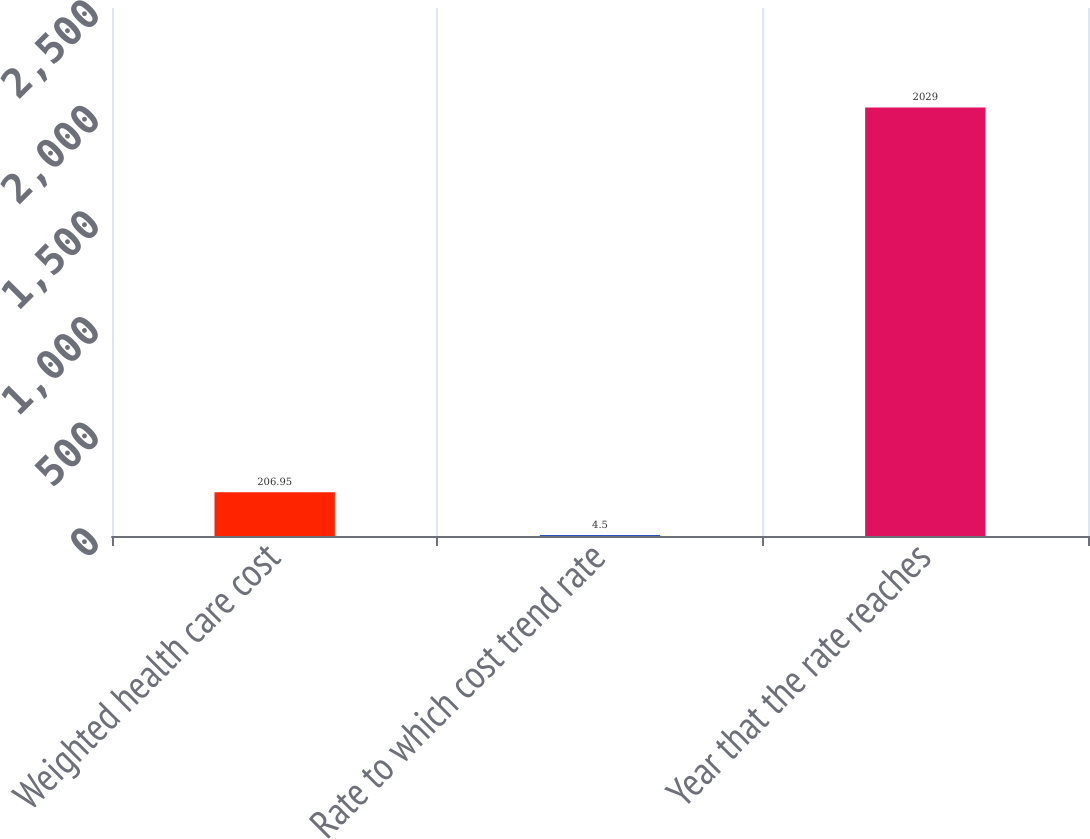Convert chart to OTSL. <chart><loc_0><loc_0><loc_500><loc_500><bar_chart><fcel>Weighted health care cost<fcel>Rate to which cost trend rate<fcel>Year that the rate reaches<nl><fcel>206.95<fcel>4.5<fcel>2029<nl></chart> 